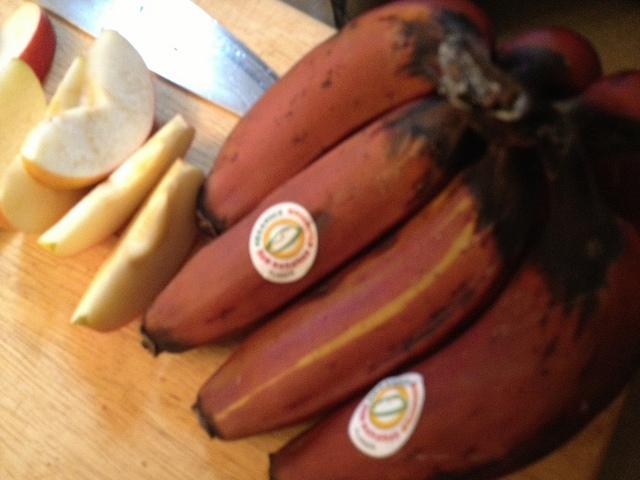Are these bananas ripe?
Give a very brief answer. Yes. Is there a knife?
Write a very short answer. Yes. Is there any fruit shown in the photo besides bananas?
Be succinct. Yes. What color is the apple?
Write a very short answer. Red. 